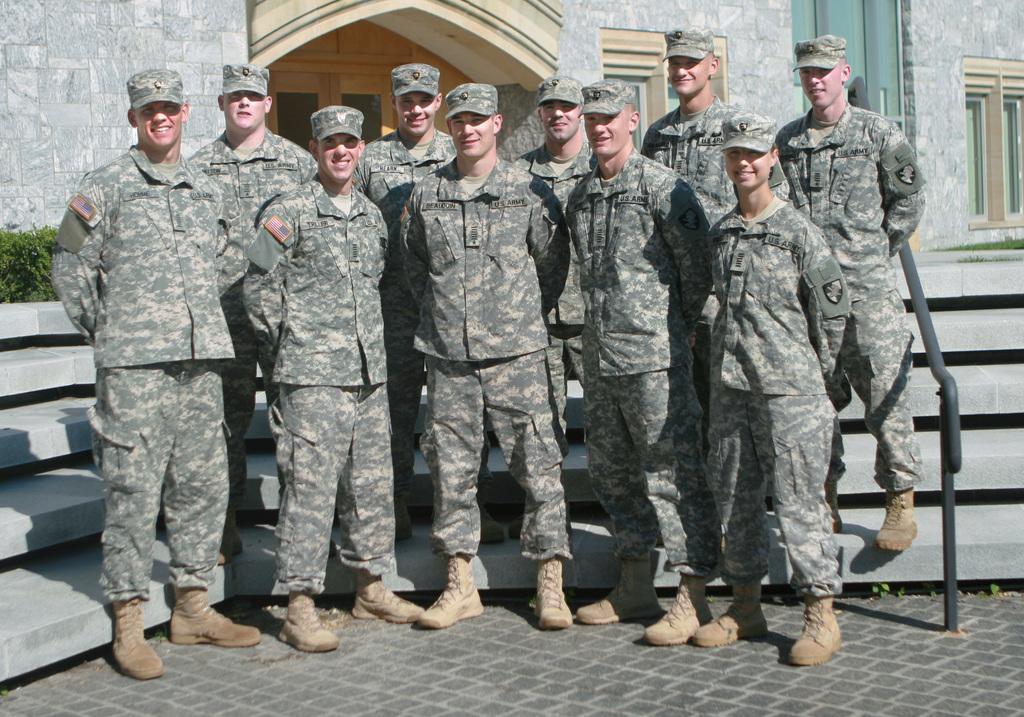Can you describe this image briefly? In this image there are group of army officers standing in the middle. In the background there is a building. Behind the officers there are steps. 